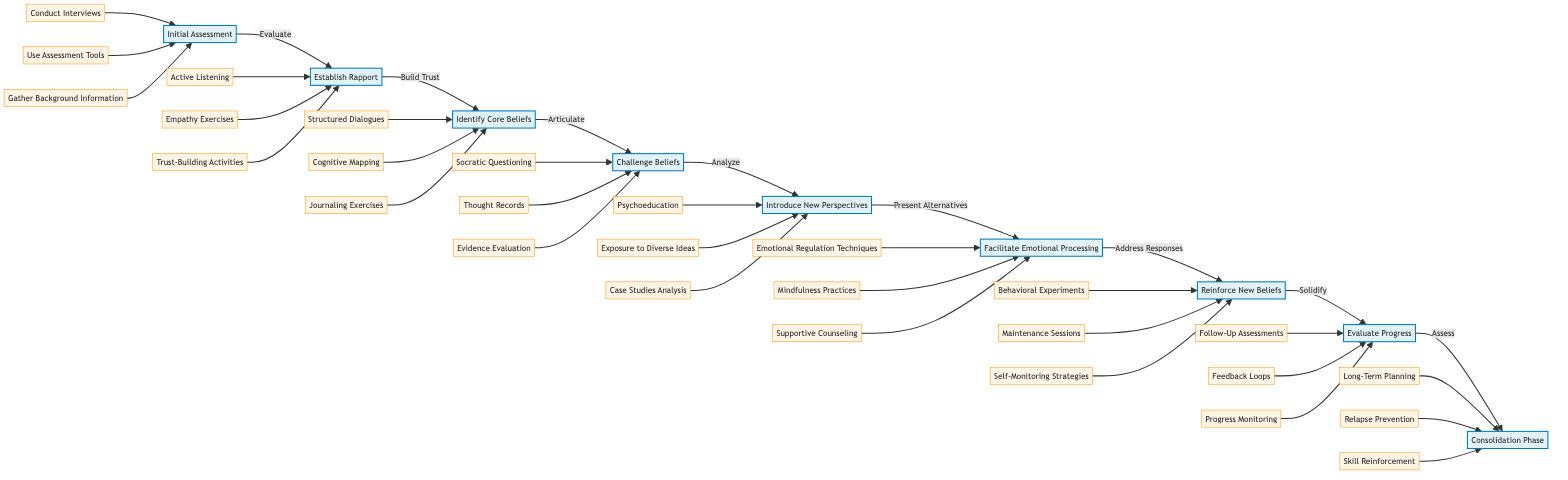What is the first step in the counseling techniques for addressing belief transitions? The first step is indicated by the node labeled "Initial Assessment." This node is the starting point of the flowchart and has no predecessors.
Answer: Initial Assessment How many key actions are listed under the "Challenge Beliefs" step? The "Challenge Beliefs" step has three key actions listed beneath it: Socratic Questioning, Thought Records, and Evidence Evaluation.
Answer: 3 Which step follows "Facilitate Emotional Processing"? Following the "Facilitate Emotional Processing," the diagram flows to the next step labeled "Reinforce New Beliefs." This is a direct connection from one node to the next.
Answer: Reinforce New Beliefs What is the main focus of the "Evaluate Progress" step? The main focus of the "Evaluate Progress" step is to regularly assess the client's progress, ensuring that the approach adapts as needed. This step emphasizes the importance of monitoring and adjusting strategies.
Answer: Regularly assess client’s progress What type of techniques are included in the key actions for "Facilitate Emotional Processing"? The key actions in "Facilitate Emotional Processing" are Emotional Regulation Techniques, Mindfulness Practices, and Supportive Counseling, indicating a focus on emotional support and coping skills.
Answer: Emotional Regulation Techniques, Mindfulness Practices, Supportive Counseling What is the last step in the flowchart? The last step in the flowchart is the "Consolidation Phase," which ensures stability of transitioned beliefs and prepares the client for self-directed growth.
Answer: Consolidation Phase Which step involves the use of "Journaling Exercises"? "Journaling Exercises" is listed as one of the key actions under the "Identify Core Beliefs" step. This indicates that it is used to help clients articulate their fundamental beliefs.
Answer: Identify Core Beliefs How is the relationship between "Establish Rapport" and "Identify Core Beliefs" represented in the flowchart? The relationship is represented by a direct arrow leading from "Establish Rapport" to "Identify Core Beliefs," indicating that the trust built in the previous step is necessary for identifying core beliefs.
Answer: Direct arrow What element precedes the "Introduce New Perspectives" step? The element that precedes the "Introduce New Perspectives" step is "Challenge Beliefs," which indicates that critical analysis of existing beliefs is required before presenting new alternatives.
Answer: Challenge Beliefs 